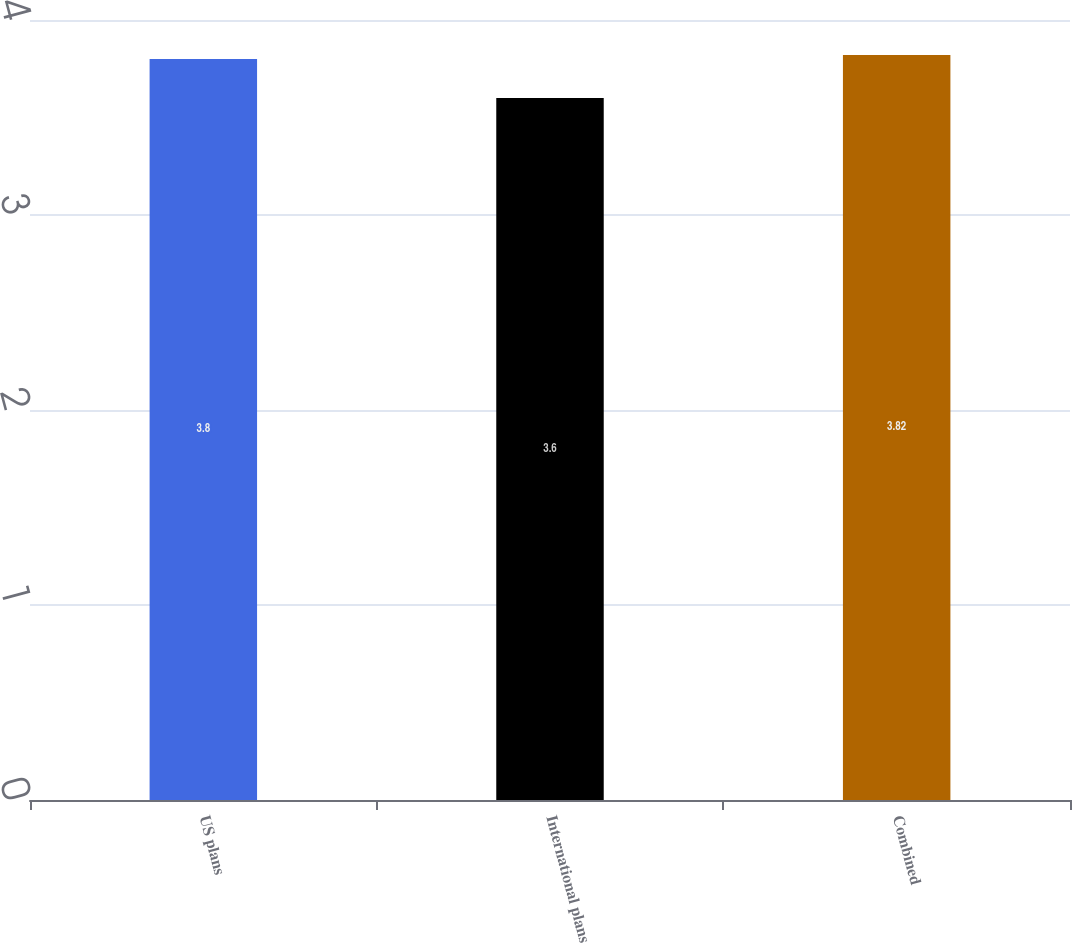<chart> <loc_0><loc_0><loc_500><loc_500><bar_chart><fcel>US plans<fcel>International plans<fcel>Combined<nl><fcel>3.8<fcel>3.6<fcel>3.82<nl></chart> 